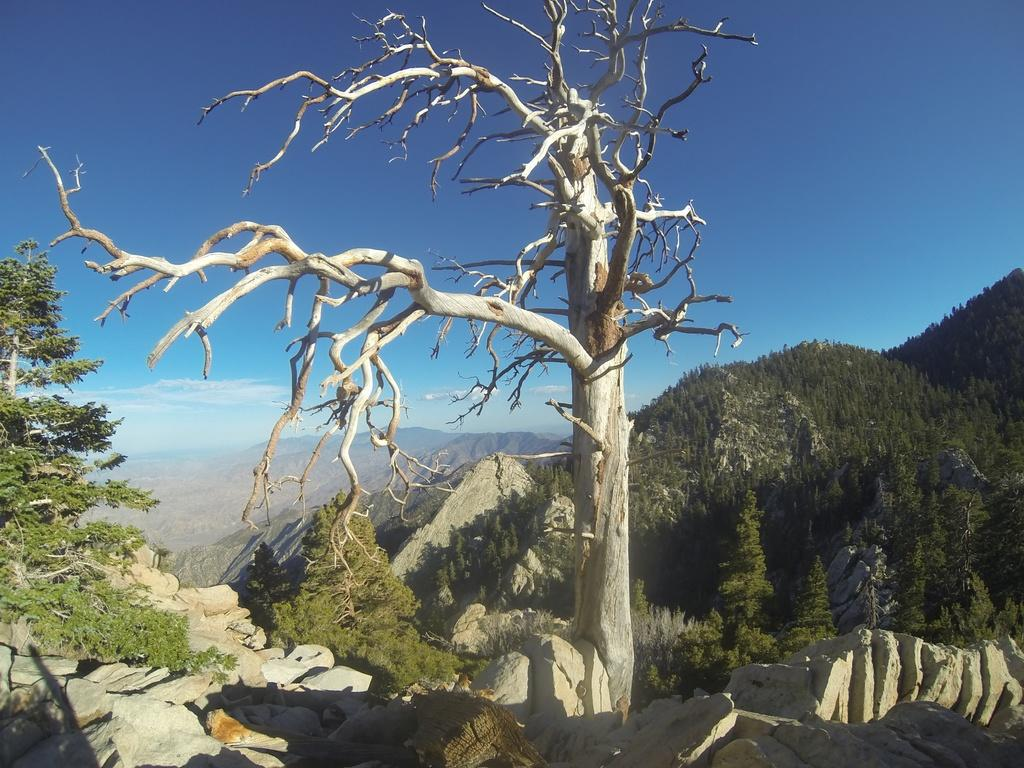What type of vegetation is present in the image? There are trees in the image. What other natural elements can be seen in the image? There are stones and mountains visible in the image. What is visible in the sky in the image? There are clouds visible in the sky in the image. What type of process is being carried out by the star in the image? There is no star present in the image, so it is not possible to determine what process might be carried out by a star. Where is the sofa located in the image? There is no sofa present in the image. 